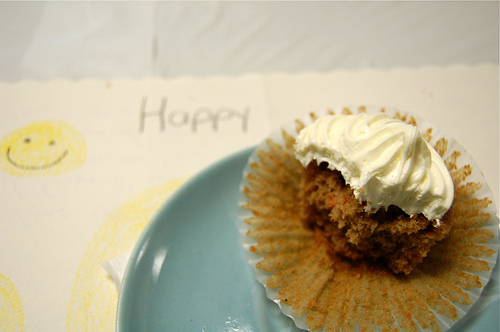Please extract the text content from this image. Happy 